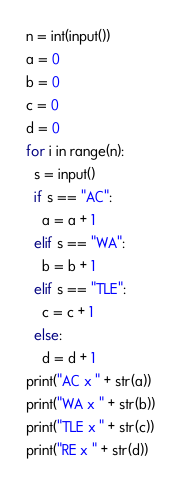<code> <loc_0><loc_0><loc_500><loc_500><_Python_>n = int(input())
a = 0
b = 0
c = 0
d = 0
for i in range(n):
  s = input()
  if s == "AC":
    a = a + 1
  elif s == "WA":
    b = b + 1
  elif s == "TLE":
    c = c + 1
  else:
    d = d + 1
print("AC x " + str(a))
print("WA x " + str(b))
print("TLE x " + str(c))
print("RE x " + str(d))
</code> 